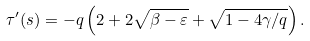Convert formula to latex. <formula><loc_0><loc_0><loc_500><loc_500>\tau ^ { \prime } ( s ) = - q \left ( 2 + 2 \sqrt { \beta - \varepsilon } + \sqrt { 1 - 4 \gamma / q } \right ) .</formula> 